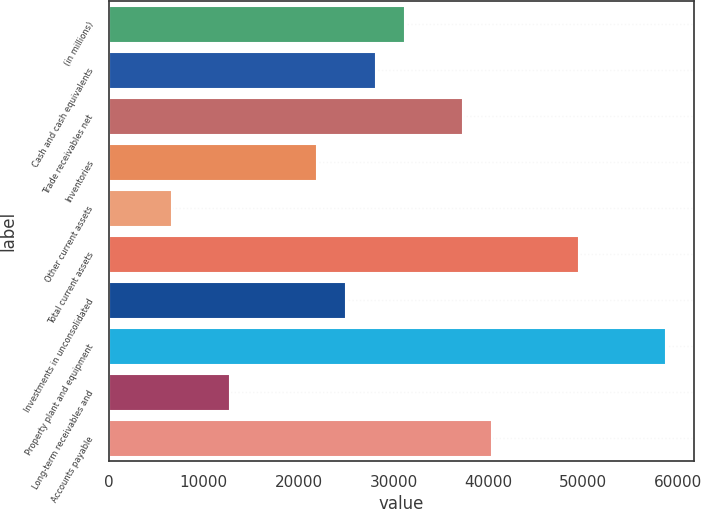Convert chart to OTSL. <chart><loc_0><loc_0><loc_500><loc_500><bar_chart><fcel>(in millions)<fcel>Cash and cash equivalents<fcel>Trade receivables net<fcel>Inventories<fcel>Other current assets<fcel>Total current assets<fcel>Investments in unconsolidated<fcel>Property plant and equipment<fcel>Long-term receivables and<fcel>Accounts payable<nl><fcel>31174<fcel>28114.7<fcel>37292.6<fcel>21996.1<fcel>6699.6<fcel>49529.8<fcel>25055.4<fcel>58707.7<fcel>12818.2<fcel>40351.9<nl></chart> 